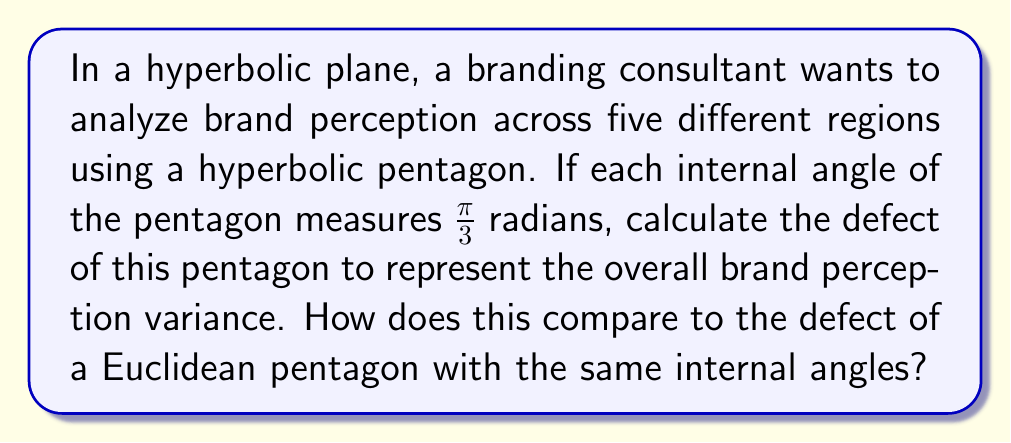What is the answer to this math problem? Let's approach this step-by-step:

1) In hyperbolic geometry, the defect of a polygon is given by:

   $$ \text{Defect} = (n-2)\pi - \sum_{i=1}^n \theta_i $$

   where $n$ is the number of sides and $\theta_i$ are the internal angles.

2) For our hyperbolic pentagon, $n = 5$ and each $\theta_i = \frac{\pi}{3}$.

3) Substituting into the formula:

   $$ \text{Defect} = (5-2)\pi - 5 \cdot \frac{\pi}{3} $$

4) Simplify:
   
   $$ \text{Defect} = 3\pi - \frac{5\pi}{3} $$

5) Find a common denominator:

   $$ \text{Defect} = \frac{9\pi}{3} - \frac{5\pi}{3} = \frac{4\pi}{3} $$

6) In Euclidean geometry, the sum of internal angles of a pentagon is always $(5-2)\pi = 3\pi$.

7) For a Euclidean pentagon with the same internal angles:

   $$ \sum_{i=1}^5 \theta_i = 5 \cdot \frac{\pi}{3} = \frac{5\pi}{3} $$

8) This is less than $3\pi$, which is impossible in Euclidean geometry. The defect in Euclidean geometry would be 0.

9) The positive defect in hyperbolic geometry represents the variance in brand perception across regions, which wouldn't be captured in a Euclidean model.
Answer: $\frac{4\pi}{3}$ radians 